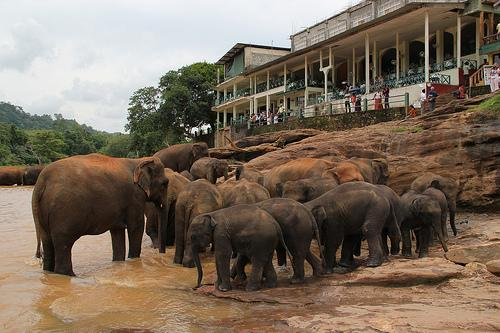What is the primary focus of this photograph, and what is happening in the scene? The primary focus is a group of elephants near the water, some of them are bathing, some standing on rocks while people watch them. Evaluate the quality of this image in terms of its content and visual appeal. The image has a high-quality content with diverse elements like elephants, people, and scenery, making it visually appealing and engaging. Out of all the objects around the area, what architectural features are present in the image? A three-story building with a flat roof, a Y-shaped column attached to the roof, and short metal railing above a wall are visible. Please provide a detailed caption for this photograph that includes key features. Elephants gather at the water to bathe and drink while people watch from a distance, with a three-story building, large rocky background, and trees visible in the scene. Explain the interaction between the elephants and the individuals observing them. People are observing the elephants from a distance as the animals bathe, drink water, and stand near the water. Use your reasoning skills to answer what might be the reason for the gathering of people around the elephants? The people are probably there to observe and appreciate the natural behavior of the elephants in their habitat, possibly in a protected park or conservation area. Express the sentiment or mood of the image in a few words. Peaceful, natural, and harmonious interaction between humans and elephants. Where are the people in the image, and what are they doing? The people are located in the background, walking up stairs, or sitting down, and they are watching the elephants. Describe an interesting characteristic of the elephants in the image. Some of the elephants are covered in mud, which helps them stay cool by coating their skin. Can you count the number of elephants around the water in this picture? There are at least 11 elephants near the water in the image. Are there any baby elephants climbing on trees in the image? The baby elephants are mentioned to be near the water, not climbing on trees. Is there a person riding one of the elephants by the water? While there are people watching the elephants, there is no mention of anyone riding the elephants. Can you spot a circular column attached to the roof? The original image only contains information about a y-shaped column attached to the roof, not a circular one. Is the woman in the red skirt and blue top standing near the stairs? The original image only contains information about a woman in red skirt and white top, not a blue top. Can you find a zebra standing by the elephants in the image? The image solely contains information about elephants, and no mention of other animals like zebras is given. Is there a mountain with no trees in the background of the image? The image specifically mentions lots of trees on the mountain, implying that it isn't tree-less. 